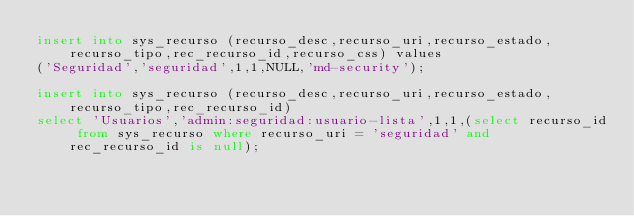<code> <loc_0><loc_0><loc_500><loc_500><_SQL_>insert into sys_recurso (recurso_desc,recurso_uri,recurso_estado,recurso_tipo,rec_recurso_id,recurso_css) values 
('Seguridad','seguridad',1,1,NULL,'md-security');

insert into sys_recurso (recurso_desc,recurso_uri,recurso_estado,recurso_tipo,rec_recurso_id)  
select 'Usuarios','admin:seguridad:usuario-lista',1,1,(select recurso_id from sys_recurso where recurso_uri = 'seguridad' and rec_recurso_id is null);
</code> 